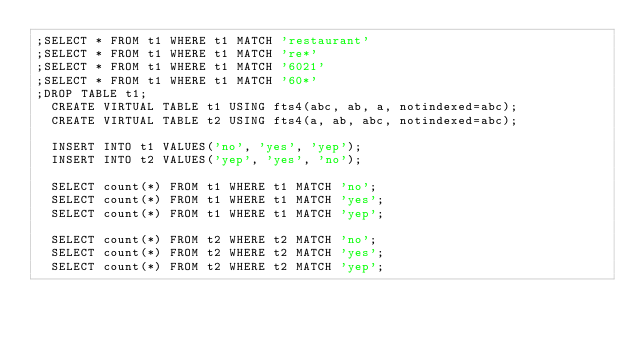Convert code to text. <code><loc_0><loc_0><loc_500><loc_500><_SQL_>;SELECT * FROM t1 WHERE t1 MATCH 'restaurant'
;SELECT * FROM t1 WHERE t1 MATCH 're*'
;SELECT * FROM t1 WHERE t1 MATCH '6021'
;SELECT * FROM t1 WHERE t1 MATCH '60*'
;DROP TABLE t1;
  CREATE VIRTUAL TABLE t1 USING fts4(abc, ab, a, notindexed=abc);
  CREATE VIRTUAL TABLE t2 USING fts4(a, ab, abc, notindexed=abc);

  INSERT INTO t1 VALUES('no', 'yes', 'yep');
  INSERT INTO t2 VALUES('yep', 'yes', 'no');

  SELECT count(*) FROM t1 WHERE t1 MATCH 'no';
  SELECT count(*) FROM t1 WHERE t1 MATCH 'yes';
  SELECT count(*) FROM t1 WHERE t1 MATCH 'yep';

  SELECT count(*) FROM t2 WHERE t2 MATCH 'no';
  SELECT count(*) FROM t2 WHERE t2 MATCH 'yes';
  SELECT count(*) FROM t2 WHERE t2 MATCH 'yep';</code> 